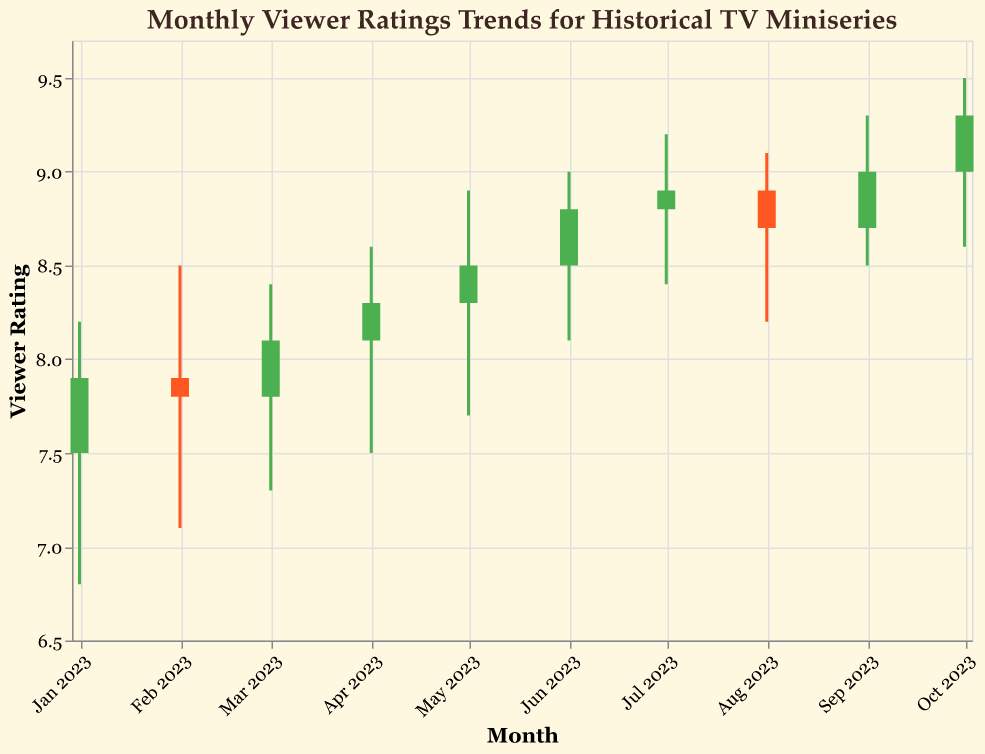What is the title of the figure? The title of the figure is usually located at the top of the chart. In this case, it states "Monthly Viewer Ratings Trends for Historical TV Miniseries".
Answer: Monthly Viewer Ratings Trends for Historical TV Miniseries How many months of data are shown in the figure? Each candlestick represents data for one month, and since there are 10 candlesticks, it indicates that 10 months of data are shown.
Answer: 10 Which month witnessed the highest viewer rating, and what was it? To determine this, look for the candlestick with the highest "High" value, which is in October 2023 with a rating of 9.5.
Answer: October 2023, 9.5 What was the lowest viewer rating in August 2023? Locate the candlestick for August 2023 and identify the lowest value, which is indicated by the "Low" point. In this case, it is 8.2.
Answer: 8.2 During which month did the viewer rating increase the most from open to close? To find this, compare the difference between the "Close" and "Open" values for each month. The biggest difference is in March 2023, with an increase of 0.3 (8.1 - 7.8).
Answer: March 2023 What is the overall trend in viewer ratings from January 2023 to October 2023? Observe the general direction of the "Close" values from January to October. The ratings show a general upward trend, increasing from 7.9 in January to 9.3 in October.
Answer: Upward trend Compare the viewer ratings between July and August 2023. Which month had a higher closing rating? Look at the "Close" values for both months. July has a closing rating of 8.9, and August has a closing rating of 8.7. Hence, July is higher.
Answer: July What is the average closing rating over the 10-month period? Sum the "Close" values (7.9 + 7.8 + 8.1 + 8.3 + 8.5 + 8.8 + 8.9 + 8.7 + 9.0 + 9.3) which equals 85.3. Divide by 10 to get the average: 85.3/10 = 8.53.
Answer: 8.53 